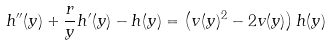Convert formula to latex. <formula><loc_0><loc_0><loc_500><loc_500>h ^ { \prime \prime } ( y ) + \frac { r } { y } h ^ { \prime } ( y ) - h ( y ) = \left ( v ( y ) ^ { 2 } - 2 v ( y ) \right ) h ( y )</formula> 